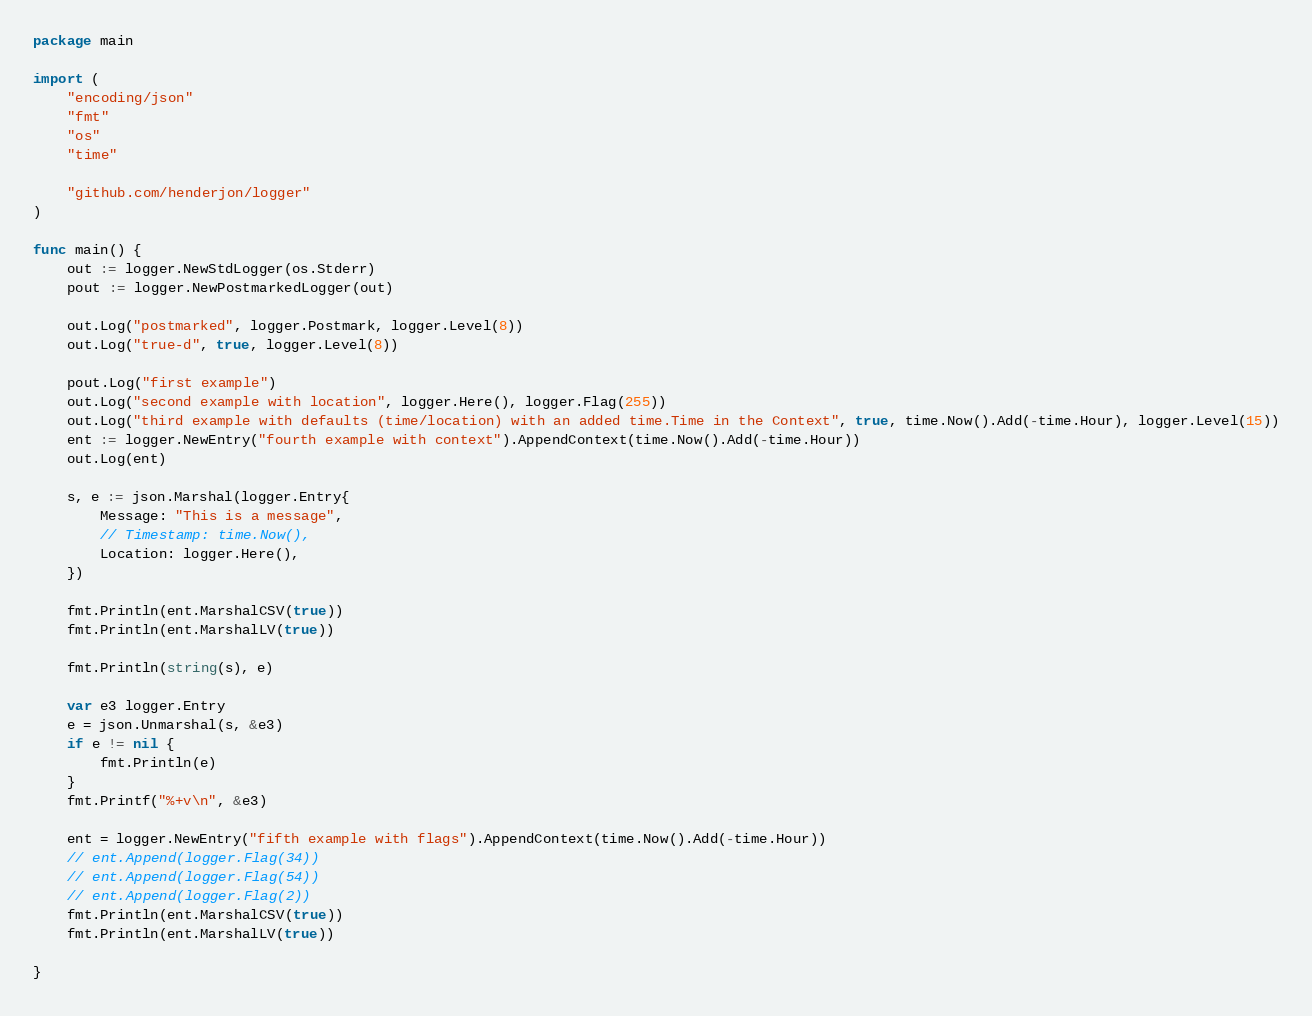<code> <loc_0><loc_0><loc_500><loc_500><_Go_>package main

import (
	"encoding/json"
	"fmt"
	"os"
	"time"

	"github.com/henderjon/logger"
)

func main() {
	out := logger.NewStdLogger(os.Stderr)
	pout := logger.NewPostmarkedLogger(out)

	out.Log("postmarked", logger.Postmark, logger.Level(8))
	out.Log("true-d", true, logger.Level(8))

	pout.Log("first example")
	out.Log("second example with location", logger.Here(), logger.Flag(255))
	out.Log("third example with defaults (time/location) with an added time.Time in the Context", true, time.Now().Add(-time.Hour), logger.Level(15))
	ent := logger.NewEntry("fourth example with context").AppendContext(time.Now().Add(-time.Hour))
	out.Log(ent)

	s, e := json.Marshal(logger.Entry{
		Message: "This is a message",
		// Timestamp: time.Now(),
		Location: logger.Here(),
	})

	fmt.Println(ent.MarshalCSV(true))
	fmt.Println(ent.MarshalLV(true))

	fmt.Println(string(s), e)

	var e3 logger.Entry
	e = json.Unmarshal(s, &e3)
	if e != nil {
		fmt.Println(e)
	}
	fmt.Printf("%+v\n", &e3)

	ent = logger.NewEntry("fifth example with flags").AppendContext(time.Now().Add(-time.Hour))
	// ent.Append(logger.Flag(34))
	// ent.Append(logger.Flag(54))
	// ent.Append(logger.Flag(2))
	fmt.Println(ent.MarshalCSV(true))
	fmt.Println(ent.MarshalLV(true))

}
</code> 